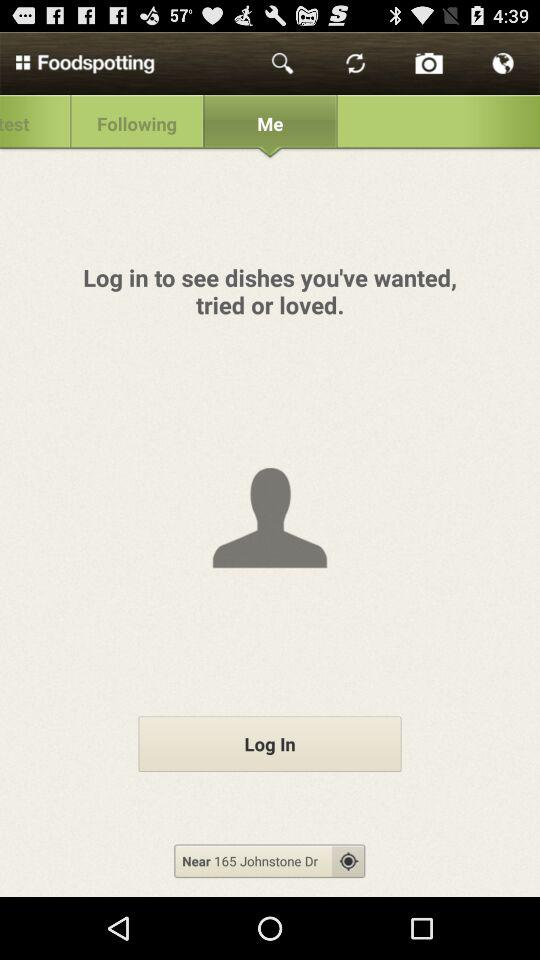What is the searched location? The searched location is 165 Johnstone Dr. 